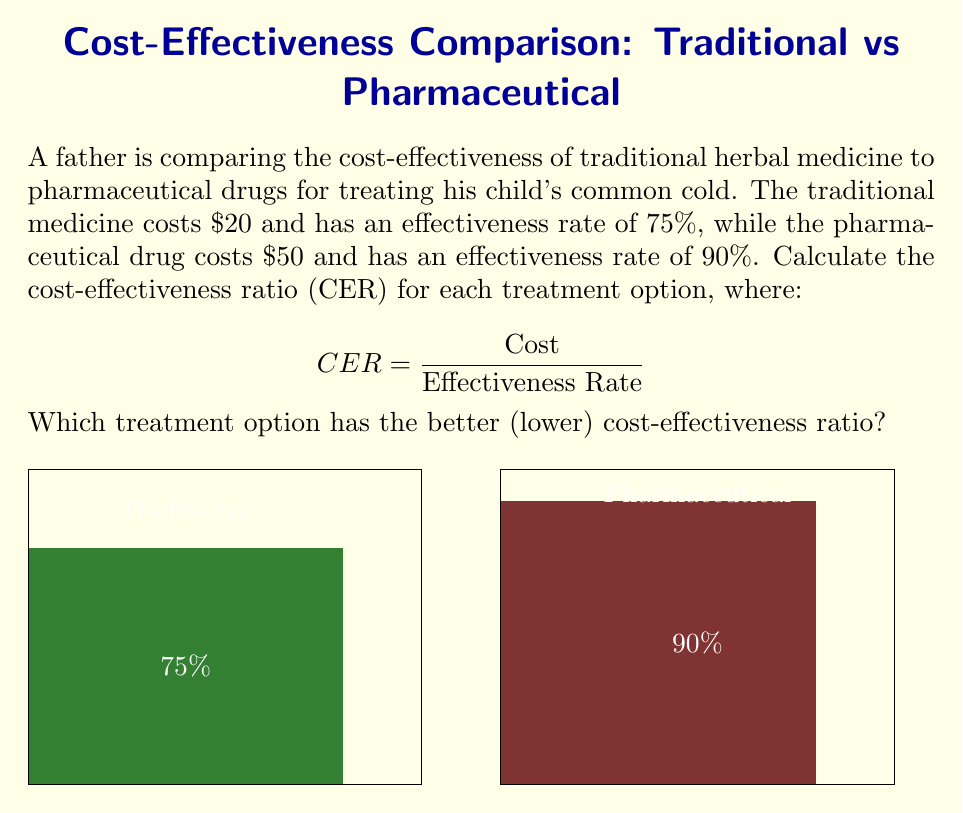Give your solution to this math problem. Let's solve this step-by-step:

1) For the traditional herbal medicine:
   Cost = $20
   Effectiveness Rate = 75% = 0.75
   
   $$ CER_{traditional} = \frac{20}{0.75} = \frac{80}{3} \approx 26.67 $$

2) For the pharmaceutical drug:
   Cost = $50
   Effectiveness Rate = 90% = 0.90
   
   $$ CER_{pharmaceutical} = \frac{50}{0.90} = \frac{500}{9} \approx 55.56 $$

3) Compare the two CER values:
   $$ CER_{traditional} \approx 26.67 < CER_{pharmaceutical} \approx 55.56 $$

4) The lower CER indicates better cost-effectiveness.
Answer: Traditional medicine has the better (lower) cost-effectiveness ratio: $\frac{80}{3}$ vs $\frac{500}{9}$. 